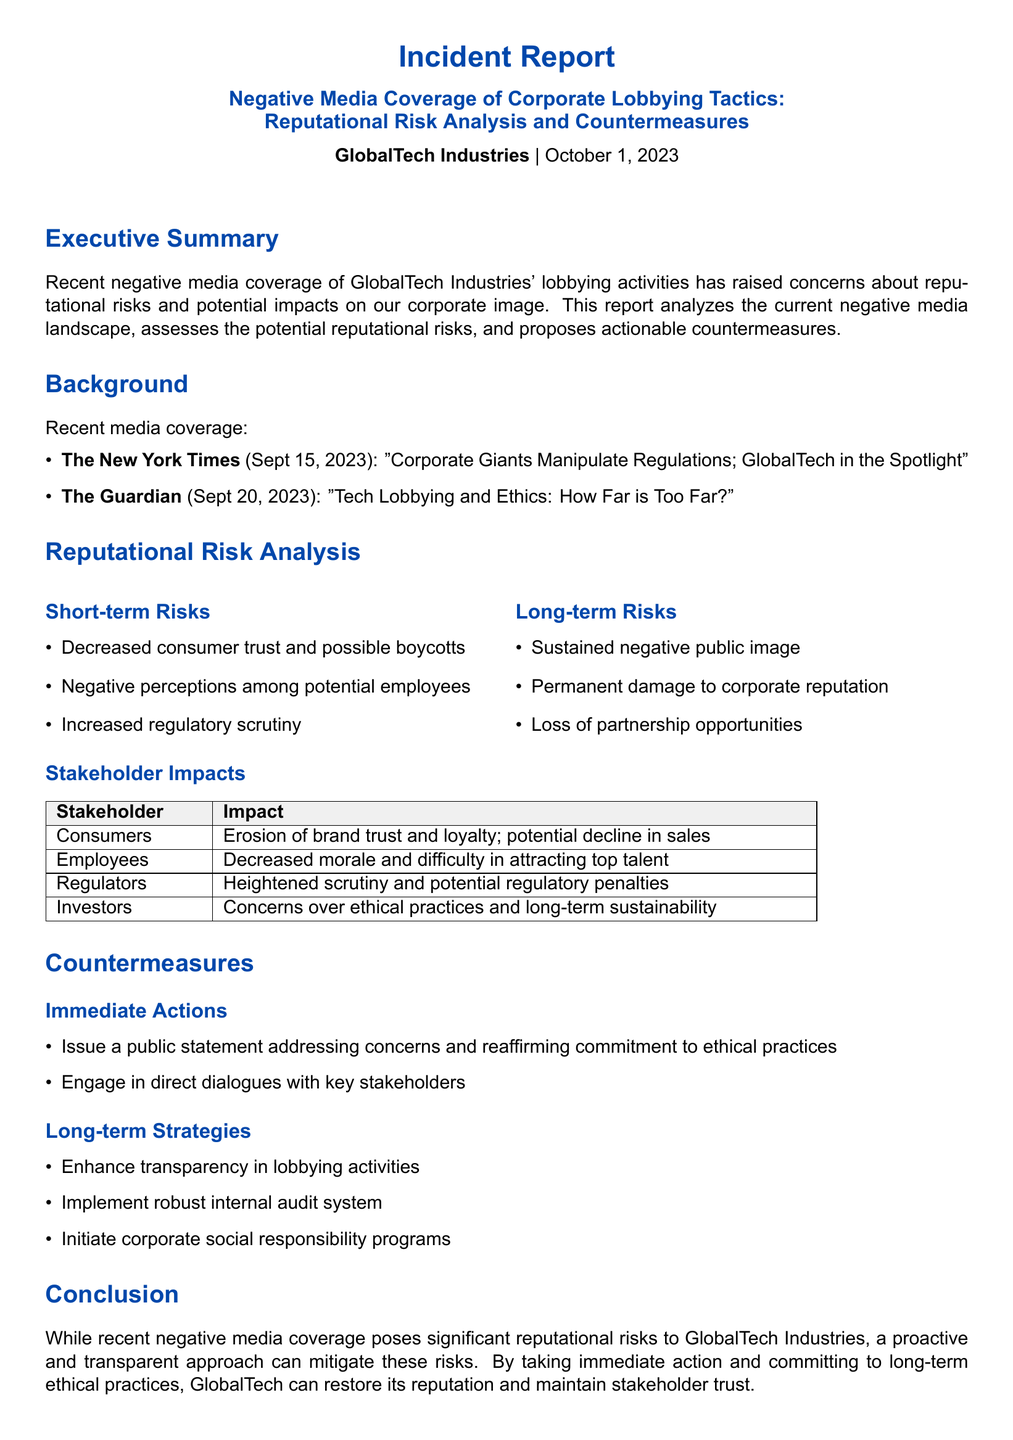What is the date of the report? The report is dated October 1, 2023.
Answer: October 1, 2023 Which publication featured the article "Corporate Giants Manipulate Regulations; GlobalTech in the Spotlight"? The article was featured in The New York Times.
Answer: The New York Times What is one of the short-term risks identified in the report? One short-term risk mentioned is "Decreased consumer trust and possible boycotts."
Answer: Decreased consumer trust and possible boycotts Name one stakeholder impacted by the negative media coverage. One impacted stakeholder is "Consumers."
Answer: Consumers What is one of the immediate actions proposed in the countermeasures? One proposed immediate action is to "Issue a public statement addressing concerns."
Answer: Issue a public statement addressing concerns What is the main purpose of the report? The main purpose of the report is to analyze the current negative media landscape and assess reputational risks.
Answer: Analyze the current negative media landscape and assess reputational risks 